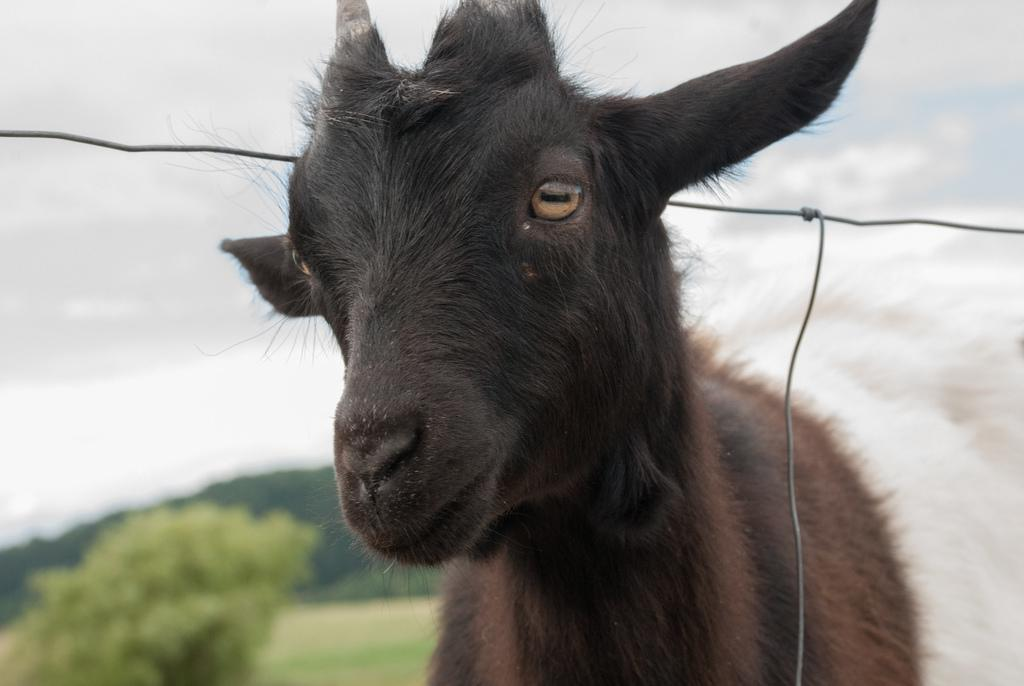What animal can be seen in the picture? There is a goat in the picture. What can be seen in the background of the picture? There are trees and the sky visible in the background of the picture. How many stones can be seen in the goat's eyes in the image? There are no stones present in the goat's eyes in the image, as goats do not have stones in their eyes. 